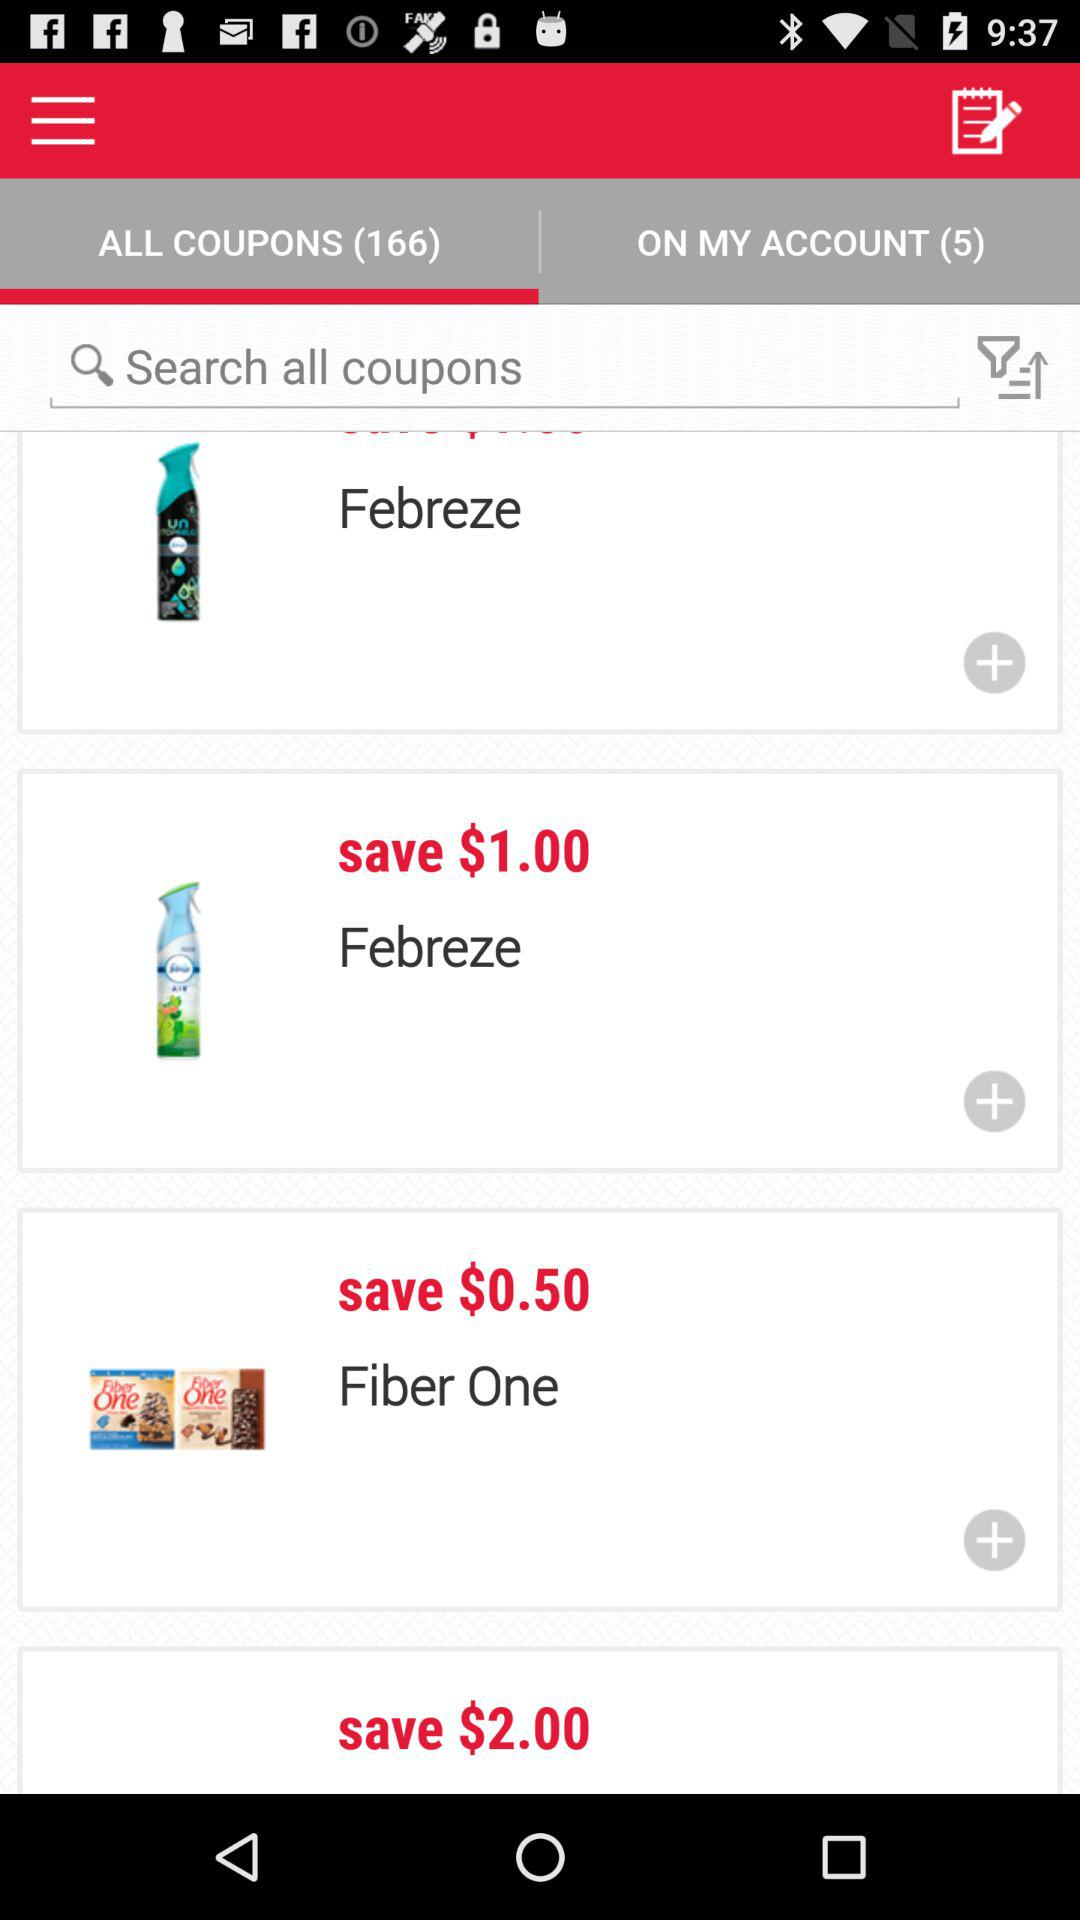How many coupons are available? There are 166 coupons available. 